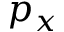<formula> <loc_0><loc_0><loc_500><loc_500>p _ { x }</formula> 